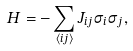<formula> <loc_0><loc_0><loc_500><loc_500>H = - \sum _ { \langle i j \rangle } J _ { i j } \sigma _ { i } \sigma _ { j } ,</formula> 